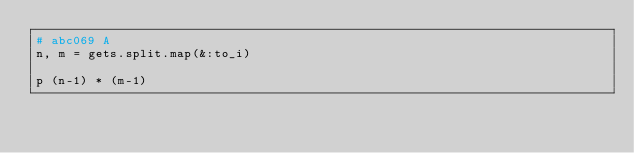Convert code to text. <code><loc_0><loc_0><loc_500><loc_500><_Ruby_># abc069 A
n, m = gets.split.map(&:to_i)

p (n-1) * (m-1)

</code> 